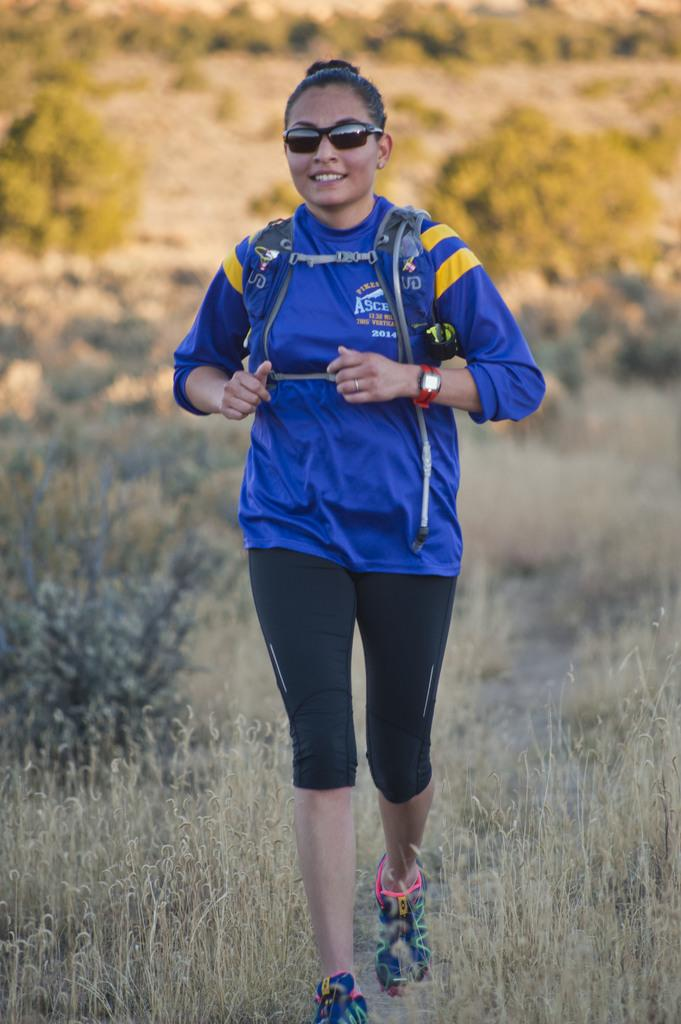Who is the main subject in the image? A: There is a woman in the image. What is the woman wearing on her face? The woman is wearing goggles. What accessory is the woman wearing on her wrist? The woman is wearing a watch. What is the woman carrying on her back? The woman is wearing a backpack. What action is the woman performing in the image? It appears that the woman is walking. What type of vegetation is at the bottom of the image? There is grass at the bottom of the image. What type of vegetation is in the middle of the image? There are bushes in the middle of the image. Where is the sink located in the image? There is no sink present in the image. How many people are in the group walking in the image? There is no group of people walking in the image; it only features a single woman. 